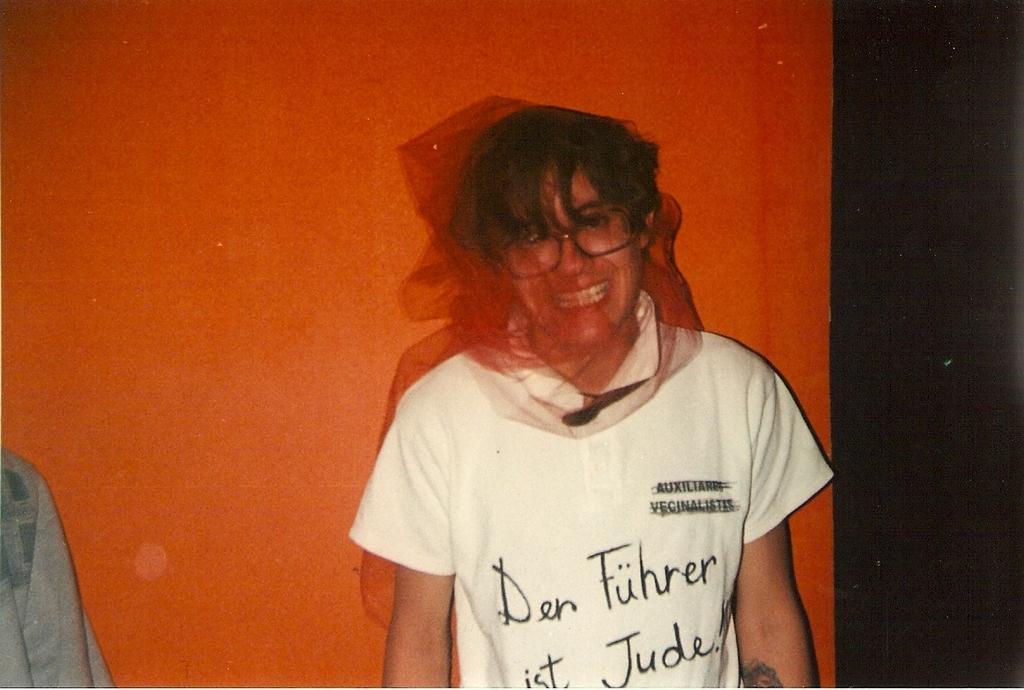Can you describe this image briefly? In this picture I can see a human standing looks like he wore a mask on his face and I can see some text on his t-shirt and a tattoo on his hand and I can see orange color background and a cloth on the left side of the picture. 